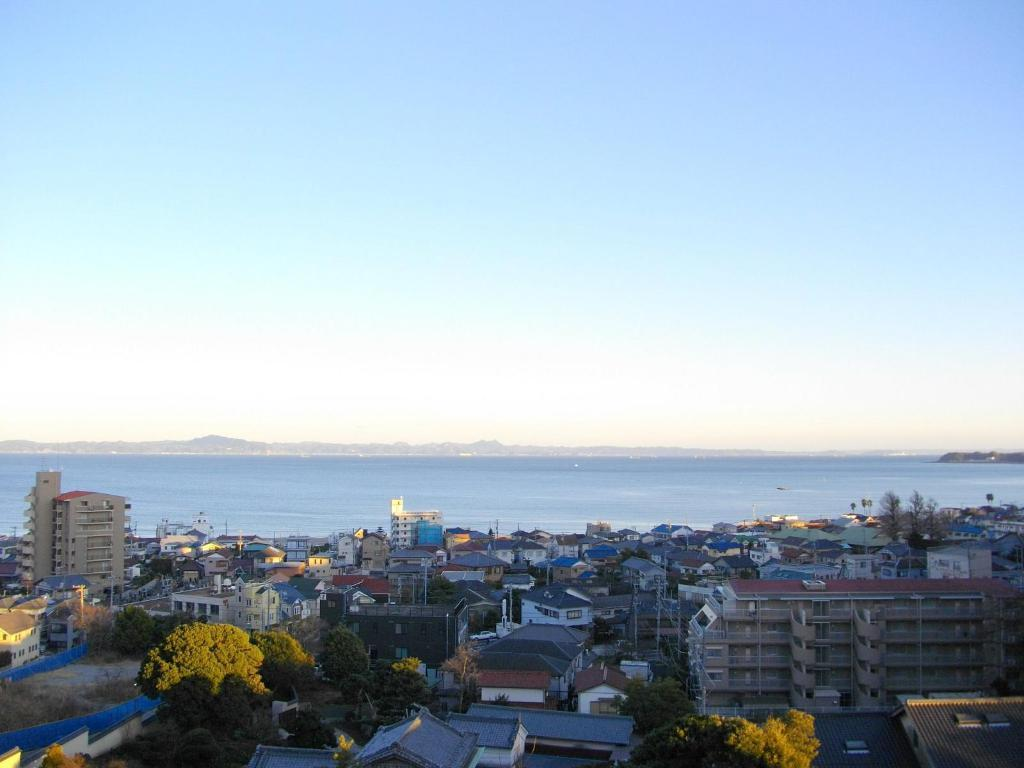What type of natural elements can be seen in the image? There are trees in the image. What type of man-made structures are present in the image? There are buildings in the image. What can be seen in the background of the image? The water and the clear sky are visible in the background of the image. Where is the faucet located in the image? There is no faucet present in the image. How many legs can be seen on the trees in the image? Trees do not have legs; they have trunks and branches. 